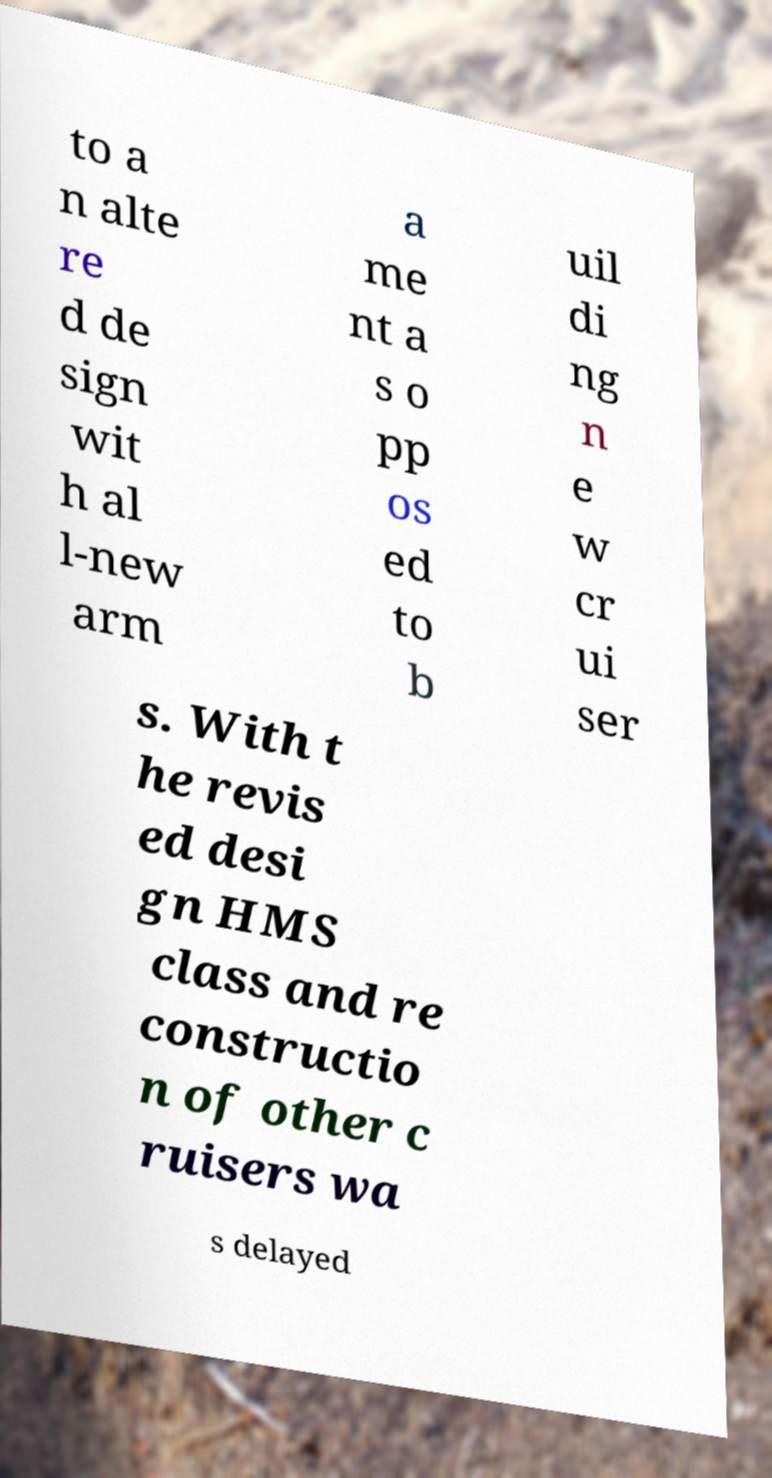Please read and relay the text visible in this image. What does it say? to a n alte re d de sign wit h al l-new arm a me nt a s o pp os ed to b uil di ng n e w cr ui ser s. With t he revis ed desi gn HMS class and re constructio n of other c ruisers wa s delayed 